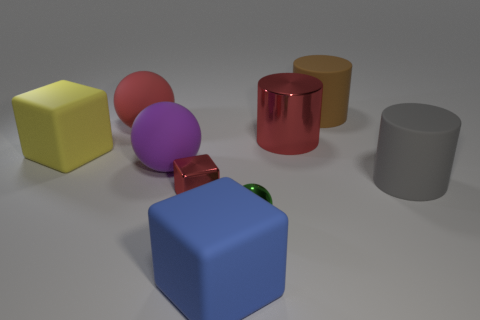There is a blue matte block that is in front of the big block behind the tiny green metallic thing; what size is it?
Keep it short and to the point. Large. There is a big object that is both behind the big purple ball and in front of the metallic cylinder; what is its color?
Your answer should be very brief. Yellow. Do the gray matte object and the large purple matte object have the same shape?
Your response must be concise. No. What is the size of the shiny block that is the same color as the big metallic cylinder?
Ensure brevity in your answer.  Small. There is a small metallic object that is in front of the tiny shiny cube in front of the big brown thing; what is its shape?
Your answer should be compact. Sphere. There is a blue thing; is it the same shape as the red object that is in front of the large gray cylinder?
Offer a very short reply. Yes. There is a metal thing that is the same size as the blue rubber cube; what color is it?
Your answer should be compact. Red. Is the number of big yellow blocks behind the large yellow rubber block less than the number of red things in front of the tiny ball?
Keep it short and to the point. No. The metallic object left of the blue rubber object right of the red shiny object in front of the large yellow rubber thing is what shape?
Your answer should be compact. Cube. There is a tiny thing that is left of the shiny sphere; is it the same color as the cylinder in front of the large yellow matte cube?
Your answer should be compact. No. 